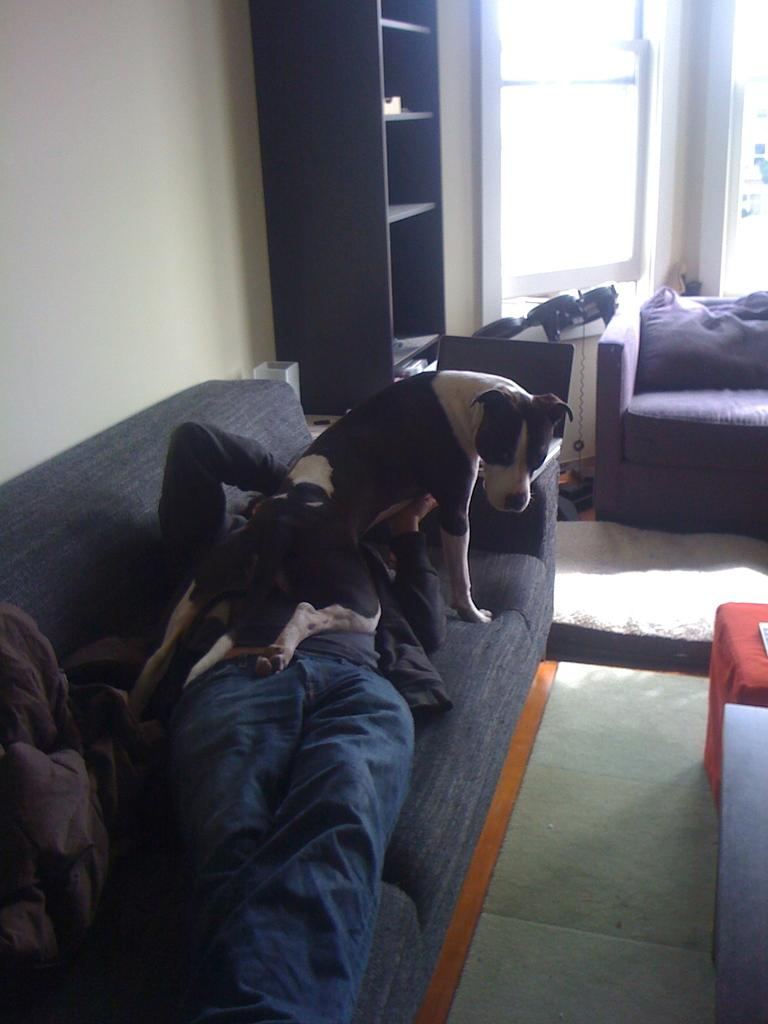What is the person in the image doing? There is a person laying on a sofa in the image. What is on top of the person? A dog is on the person. What furniture is in front of the sofa? There is a table and a chair in front of the sofa. Can you describe the background of the image? There is a chair and racks in the background, as well as a window. What type of volcano can be seen erupting in the background of the image? There is no volcano present in the image; it features a person laying on a sofa with a dog on top, surrounded by furniture and a window in the background. 